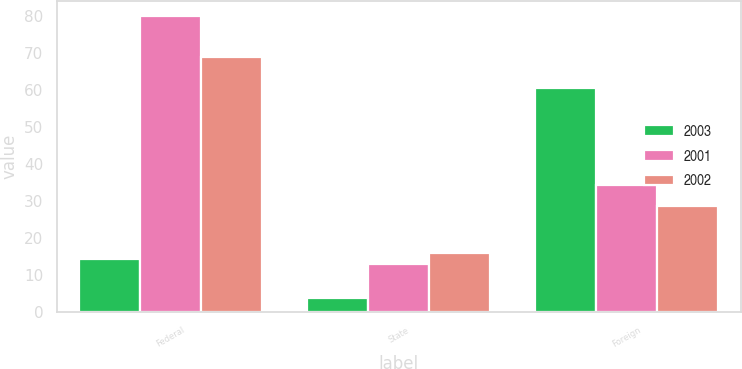Convert chart. <chart><loc_0><loc_0><loc_500><loc_500><stacked_bar_chart><ecel><fcel>Federal<fcel>State<fcel>Foreign<nl><fcel>2003<fcel>14.3<fcel>3.8<fcel>60.6<nl><fcel>2001<fcel>79.9<fcel>12.9<fcel>34.4<nl><fcel>2002<fcel>68.8<fcel>15.9<fcel>28.6<nl></chart> 